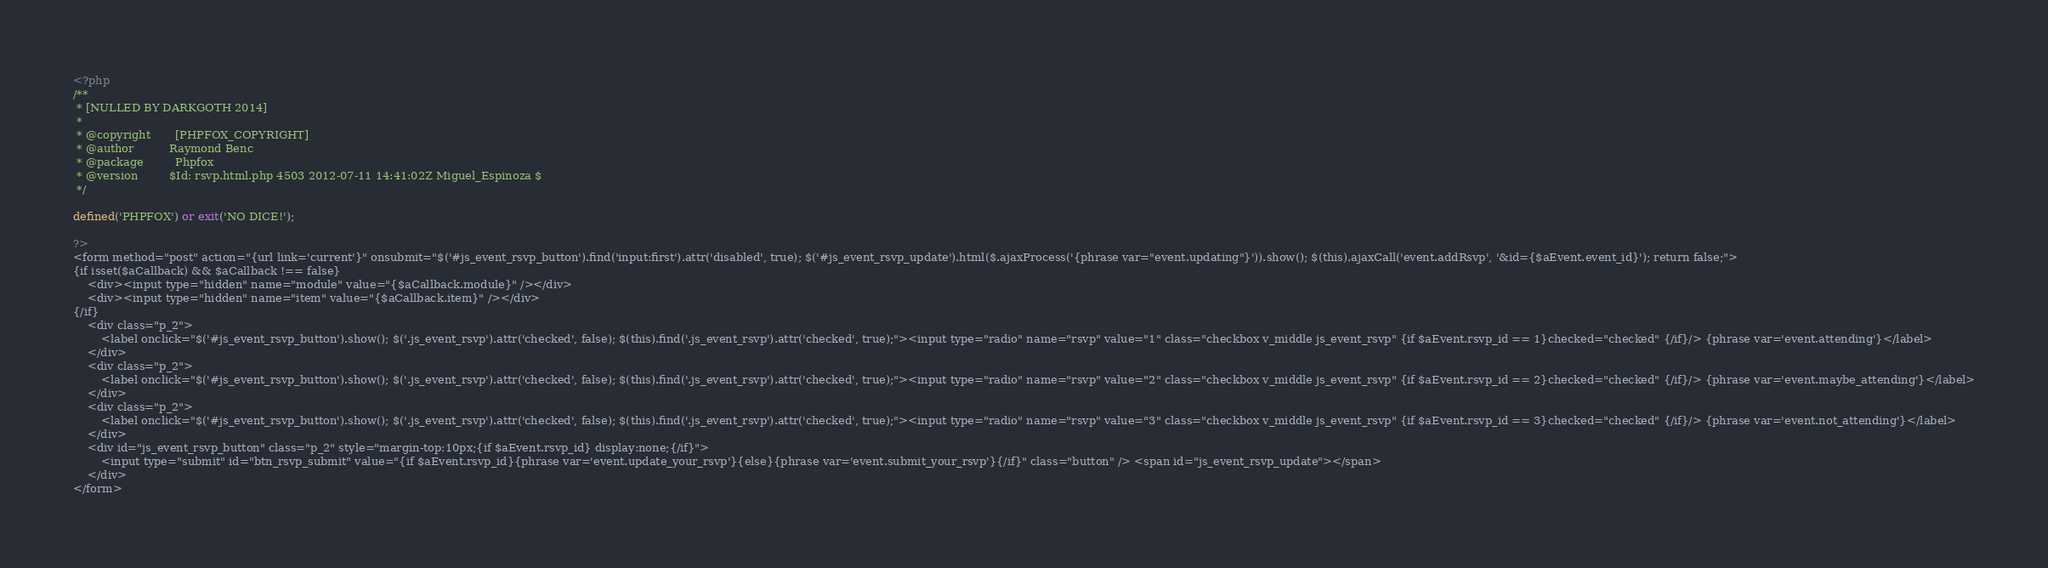<code> <loc_0><loc_0><loc_500><loc_500><_PHP_><?php 
/**
 * [NULLED BY DARKGOTH 2014]
 * 
 * @copyright		[PHPFOX_COPYRIGHT]
 * @author  		Raymond Benc
 * @package 		Phpfox
 * @version 		$Id: rsvp.html.php 4503 2012-07-11 14:41:02Z Miguel_Espinoza $
 */
 
defined('PHPFOX') or exit('NO DICE!'); 

?>
<form method="post" action="{url link='current'}" onsubmit="$('#js_event_rsvp_button').find('input:first').attr('disabled', true); $('#js_event_rsvp_update').html($.ajaxProcess('{phrase var="event.updating"}')).show(); $(this).ajaxCall('event.addRsvp', '&id={$aEvent.event_id}'); return false;">
{if isset($aCallback) && $aCallback !== false}
	<div><input type="hidden" name="module" value="{$aCallback.module}" /></div>
	<div><input type="hidden" name="item" value="{$aCallback.item}" /></div>
{/if}
	<div class="p_2">
		<label onclick="$('#js_event_rsvp_button').show(); $('.js_event_rsvp').attr('checked', false); $(this).find('.js_event_rsvp').attr('checked', true);"><input type="radio" name="rsvp" value="1" class="checkbox v_middle js_event_rsvp" {if $aEvent.rsvp_id == 1}checked="checked" {/if}/> {phrase var='event.attending'}</label>
	</div>
	<div class="p_2">
		<label onclick="$('#js_event_rsvp_button').show(); $('.js_event_rsvp').attr('checked', false); $(this).find('.js_event_rsvp').attr('checked', true);"><input type="radio" name="rsvp" value="2" class="checkbox v_middle js_event_rsvp" {if $aEvent.rsvp_id == 2}checked="checked" {/if}/> {phrase var='event.maybe_attending'}</label>
	</div>
	<div class="p_2">
		<label onclick="$('#js_event_rsvp_button').show(); $('.js_event_rsvp').attr('checked', false); $(this).find('.js_event_rsvp').attr('checked', true);"><input type="radio" name="rsvp" value="3" class="checkbox v_middle js_event_rsvp" {if $aEvent.rsvp_id == 3}checked="checked" {/if}/> {phrase var='event.not_attending'}</label>
	</div>	
	<div id="js_event_rsvp_button" class="p_2" style="margin-top:10px;{if $aEvent.rsvp_id} display:none;{/if}">
		<input type="submit" id="btn_rsvp_submit" value="{if $aEvent.rsvp_id}{phrase var='event.update_your_rsvp'}{else}{phrase var='event.submit_your_rsvp'}{/if}" class="button" /> <span id="js_event_rsvp_update"></span>
	</div>
</form></code> 